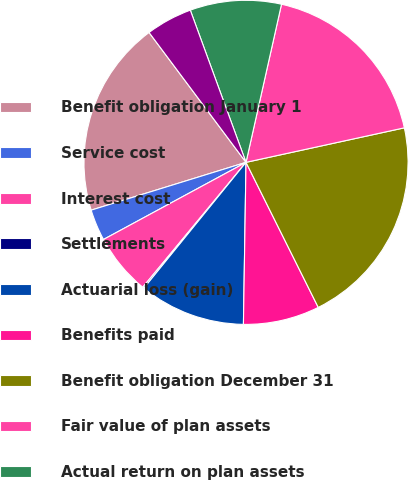<chart> <loc_0><loc_0><loc_500><loc_500><pie_chart><fcel>Benefit obligation January 1<fcel>Service cost<fcel>Interest cost<fcel>Settlements<fcel>Actuarial loss (gain)<fcel>Benefits paid<fcel>Benefit obligation December 31<fcel>Fair value of plan assets<fcel>Actual return on plan assets<fcel>Company contributions<nl><fcel>19.56%<fcel>3.13%<fcel>6.11%<fcel>0.14%<fcel>10.6%<fcel>7.61%<fcel>21.06%<fcel>18.07%<fcel>9.1%<fcel>4.62%<nl></chart> 